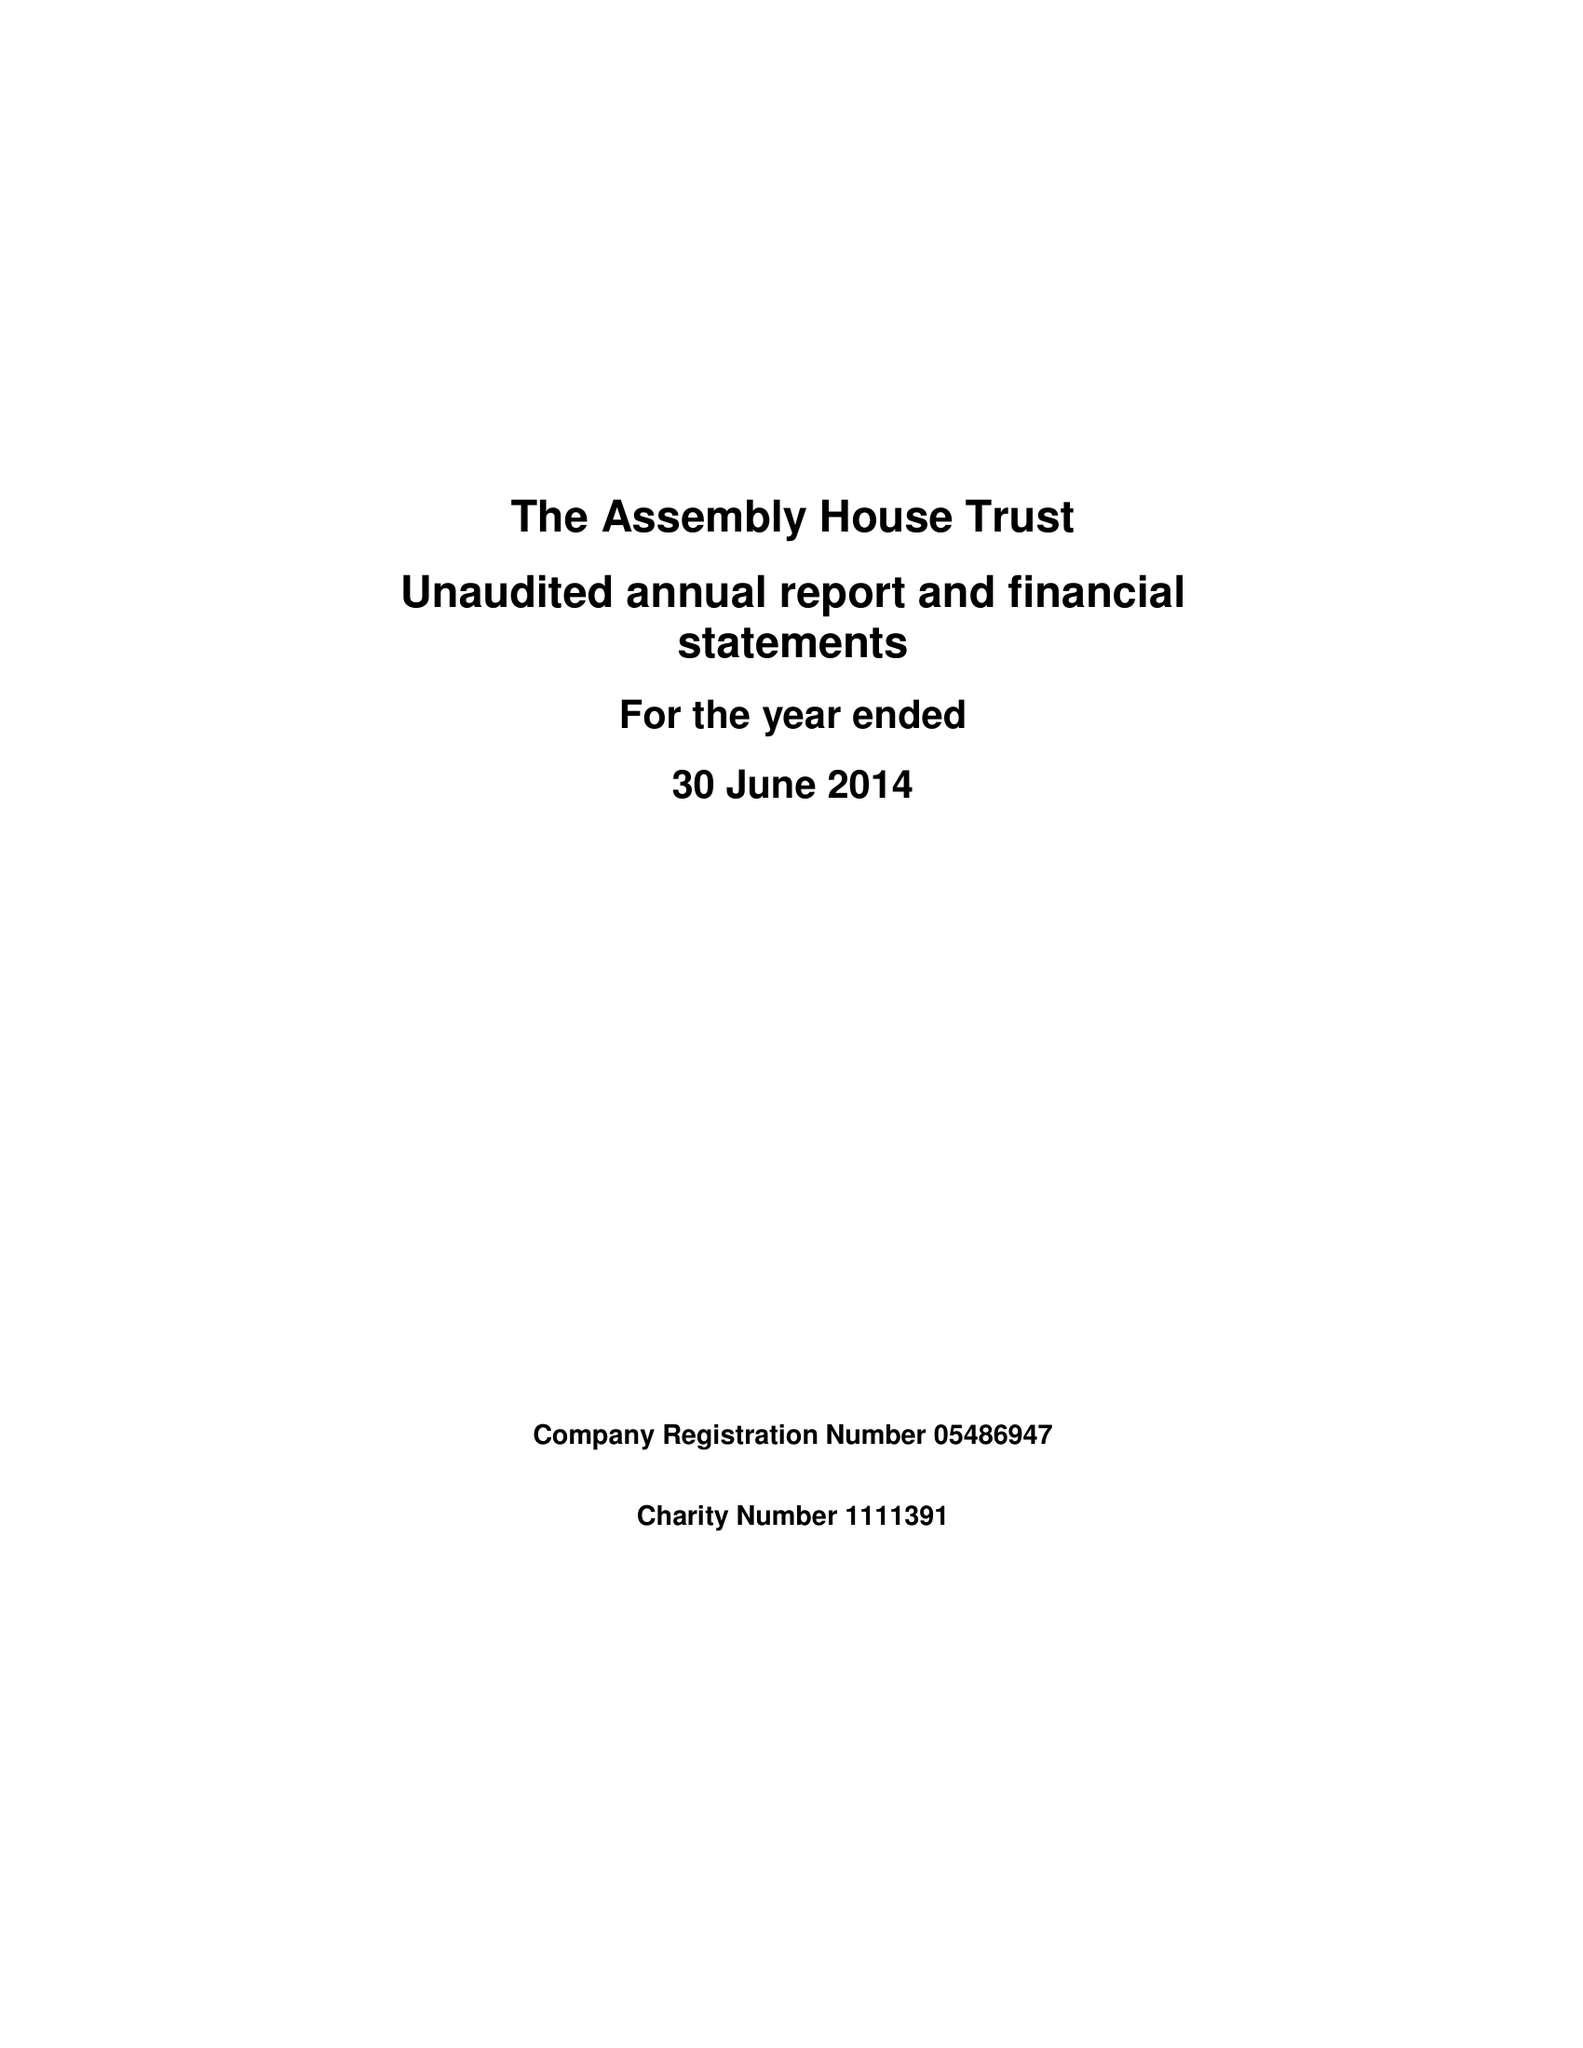What is the value for the address__post_town?
Answer the question using a single word or phrase. NORWICH 